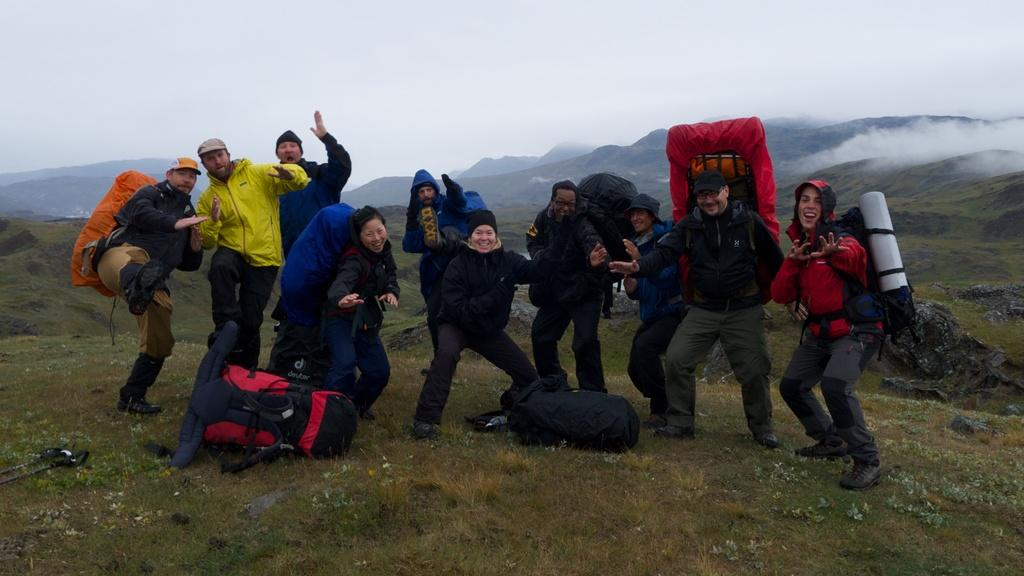Who is present in the image? There are people in the image. Where are the people located? The people are on the grass. What are the people carrying? The people are carrying bags. What can be seen in the background of the image? Hills and snow are visible in the background of the image. What is the condition of the hills? The hills are covered with grass. What type of drum is being played by the aunt in the image? There is no aunt or drum present in the image. What does the caption say about the people in the image? There is no caption provided with the image, so we cannot determine what it might say about the people. 